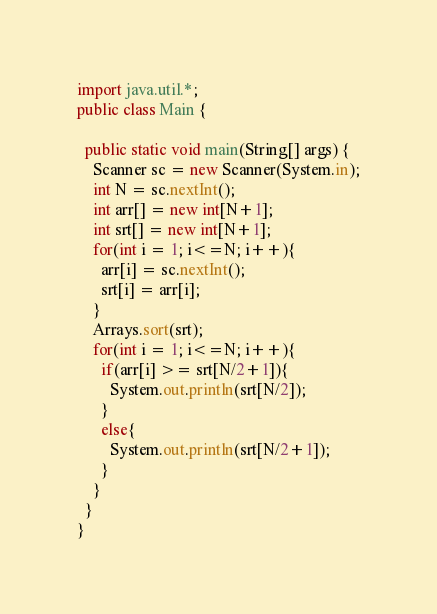Convert code to text. <code><loc_0><loc_0><loc_500><loc_500><_Java_>import java.util.*;
public class Main {

  public static void main(String[] args) {
    Scanner sc = new Scanner(System.in);
    int N = sc.nextInt();
    int arr[] = new int[N+1];
    int srt[] = new int[N+1];
    for(int i = 1; i<=N; i++){
      arr[i] = sc.nextInt();
      srt[i] = arr[i];
    }
    Arrays.sort(srt);
    for(int i = 1; i<=N; i++){
      if(arr[i] >= srt[N/2+1]){
        System.out.println(srt[N/2]); 
      }
      else{
        System.out.println(srt[N/2+1]); 
      }
    }
  }
}</code> 